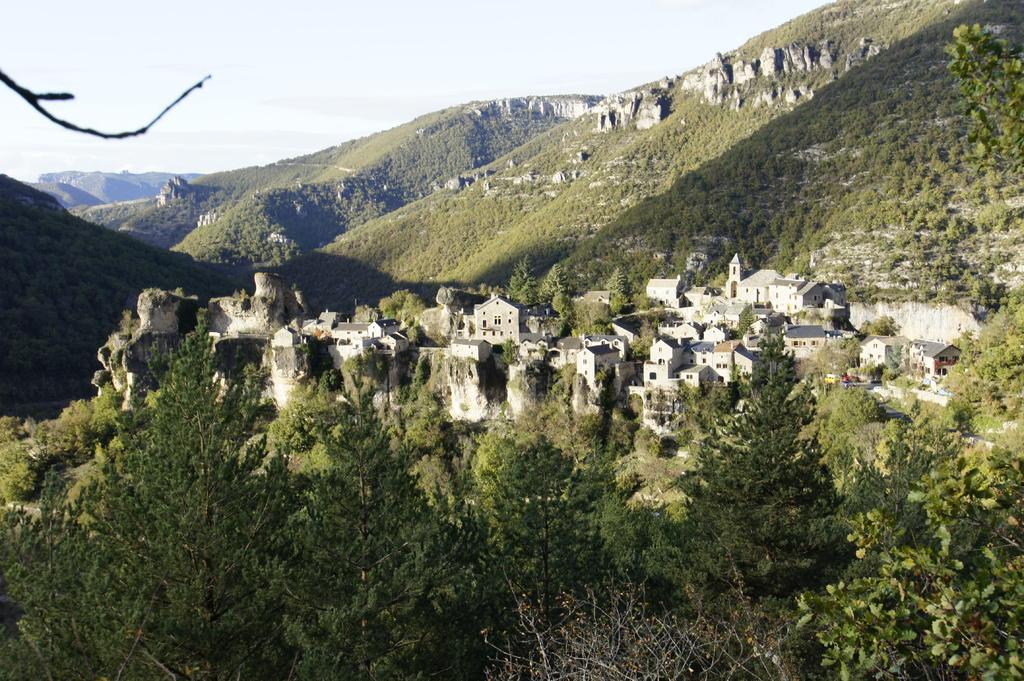In one or two sentences, can you explain what this image depicts? In this image we can see sky, hills, buildings and trees. 